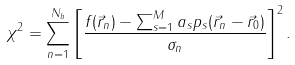Convert formula to latex. <formula><loc_0><loc_0><loc_500><loc_500>\chi ^ { 2 } = \sum _ { n = 1 } ^ { N _ { b } } \left [ \frac { f ( \vec { r } _ { n } ) - \sum _ { s = 1 } ^ { M } a _ { s } p _ { s } ( \vec { r } _ { n } - \vec { r } _ { 0 } ) } { \sigma _ { n } } \right ] ^ { 2 } .</formula> 